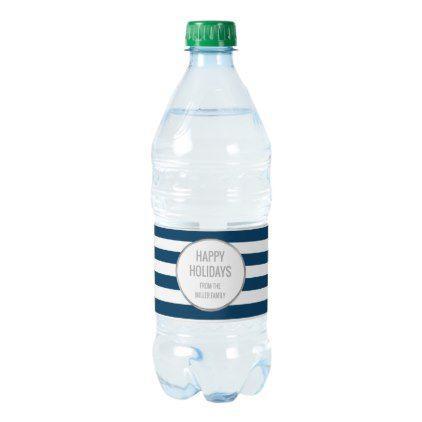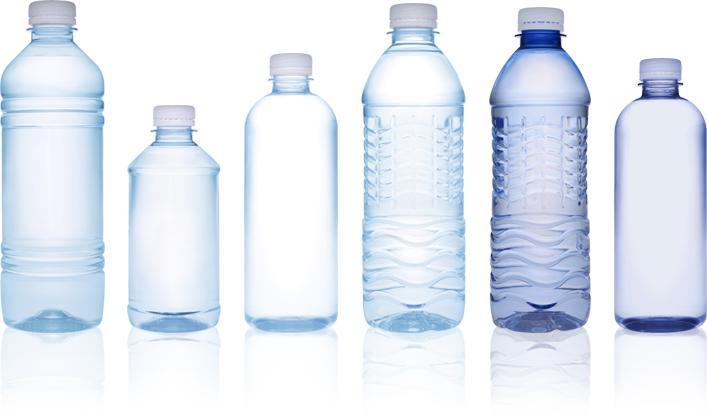The first image is the image on the left, the second image is the image on the right. Analyze the images presented: Is the assertion "In one image, three bottles have white caps and identical labels, while the second image has one or more bottles with dark caps and different labeling." valid? Answer yes or no. No. The first image is the image on the left, the second image is the image on the right. For the images shown, is this caption "The bottle on the left has a blue and white striped label and there are at least three bottles on the right hand image." true? Answer yes or no. Yes. 